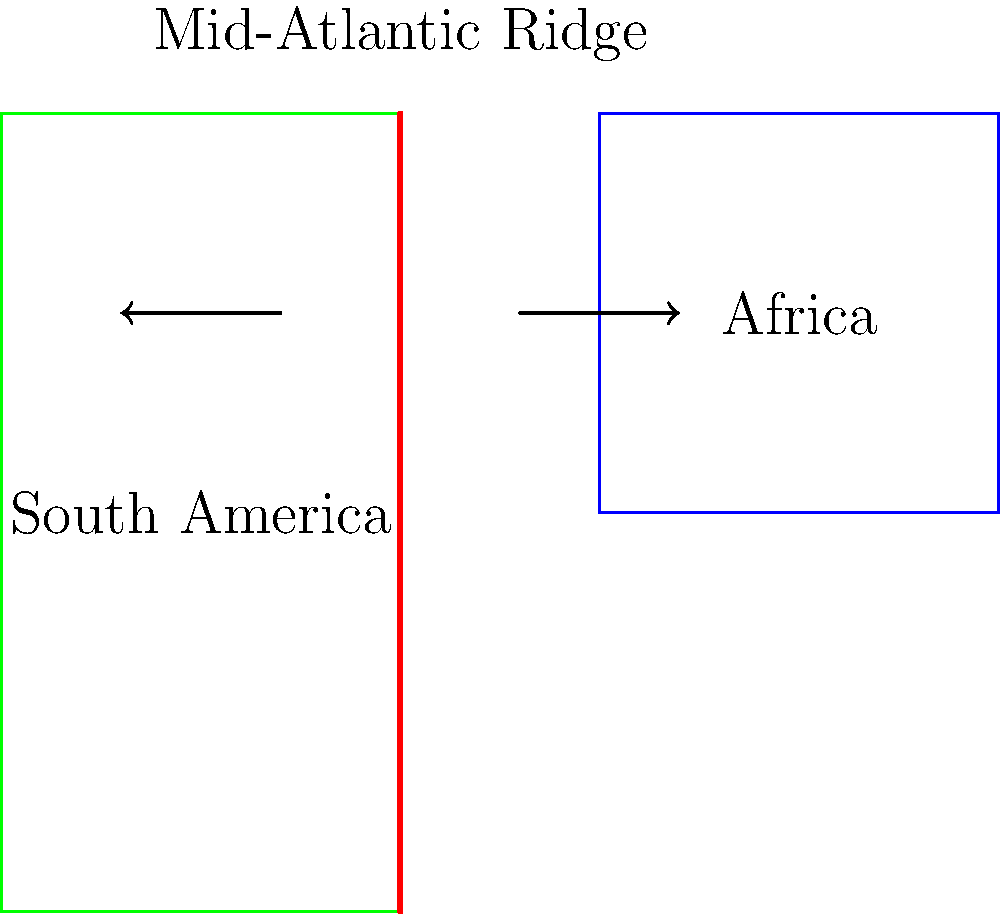Based on the map showing the tectonic plate boundary between Africa and South America, what type of plate boundary is illustrated, and in which direction are the continents moving relative to each other? To answer this question, let's analyze the map step-by-step:

1. The map shows two continents: Africa (on the right) and South America (on the left).

2. There's a red line between the continents, which represents a tectonic plate boundary. This boundary is labeled as the "Mid-Atlantic Ridge."

3. The Mid-Atlantic Ridge is a well-known divergent plate boundary. Divergent boundaries are where tectonic plates move away from each other.

4. The arrows on the map indicate the direction of plate movement:
   - The arrow on the African side points to the right (east).
   - The arrow on the South American side points to the left (west).

5. These arrows show that the continents are moving away from each other, which is consistent with a divergent boundary.

6. The Mid-Atlantic Ridge is where new oceanic crust is formed as the plates move apart, causing the Atlantic Ocean to widen over time.

Therefore, the map illustrates a divergent plate boundary, with Africa moving eastward and South America moving westward relative to each other.
Answer: Divergent boundary; Africa eastward, South America westward 